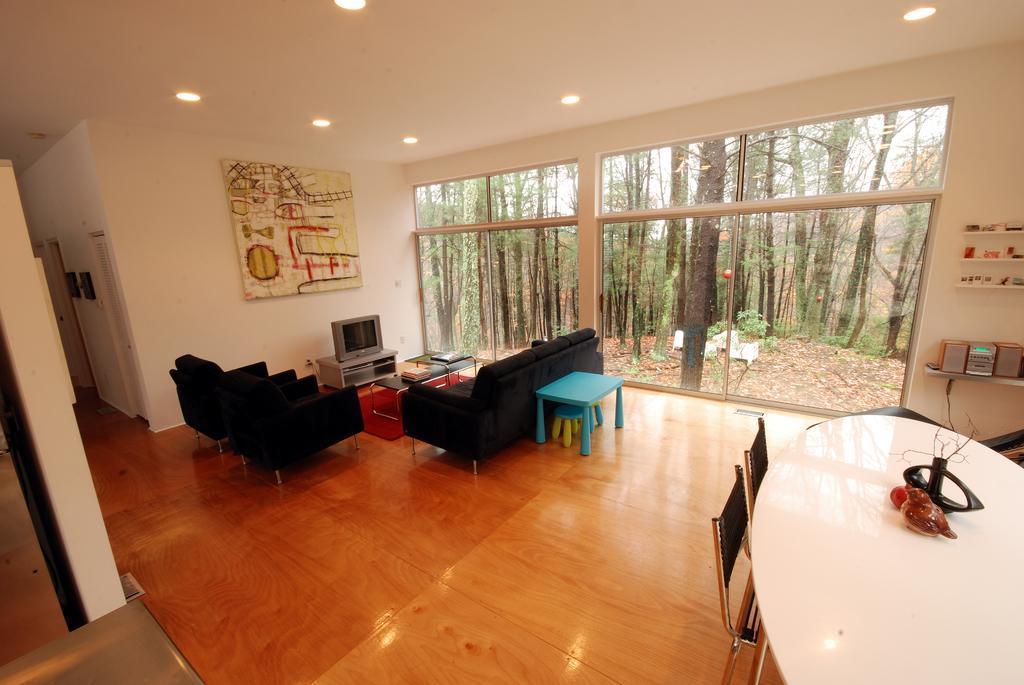Describe this image in one or two sentences. The image is taken in the room. In the center of the room there are sofas and we can see tables. There are chairs. There is a television placed on the stand. On the left there is a board placed on the wall and we can see things placed in the shelf. There are trees and we can see doors. 